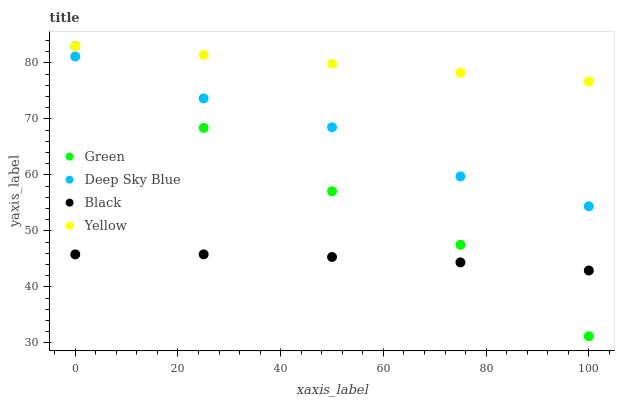Does Black have the minimum area under the curve?
Answer yes or no. Yes. Does Yellow have the maximum area under the curve?
Answer yes or no. Yes. Does Green have the minimum area under the curve?
Answer yes or no. No. Does Green have the maximum area under the curve?
Answer yes or no. No. Is Yellow the smoothest?
Answer yes or no. Yes. Is Green the roughest?
Answer yes or no. Yes. Is Green the smoothest?
Answer yes or no. No. Is Yellow the roughest?
Answer yes or no. No. Does Green have the lowest value?
Answer yes or no. Yes. Does Yellow have the lowest value?
Answer yes or no. No. Does Yellow have the highest value?
Answer yes or no. Yes. Does Deep Sky Blue have the highest value?
Answer yes or no. No. Is Black less than Deep Sky Blue?
Answer yes or no. Yes. Is Deep Sky Blue greater than Black?
Answer yes or no. Yes. Does Green intersect Yellow?
Answer yes or no. Yes. Is Green less than Yellow?
Answer yes or no. No. Is Green greater than Yellow?
Answer yes or no. No. Does Black intersect Deep Sky Blue?
Answer yes or no. No. 